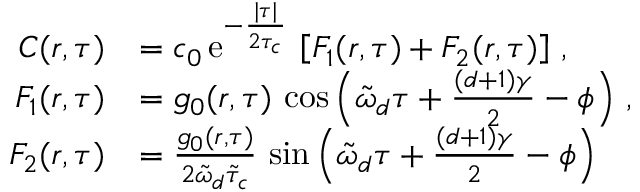Convert formula to latex. <formula><loc_0><loc_0><loc_500><loc_500>\begin{array} { r l } { C ( r , \tau ) } & { = c _ { 0 } \, e ^ { - \frac { | \tau | } { 2 \tau _ { c } } } \, \left [ F _ { 1 } ( r , \tau ) + F _ { 2 } ( r , \tau ) \right ] \, , } \\ { F _ { 1 } ( r , \tau ) } & { = g _ { 0 } ( r , \tau ) \, \cos \left ( \tilde { \omega } _ { d } \tau + \frac { ( d + 1 ) \gamma } { 2 } - \phi \right ) \, , } \\ { F _ { 2 } ( r , \tau ) } & { = \frac { g _ { 0 } ( r , \tau ) } { 2 \tilde { \omega } _ { d } \tilde { \tau } _ { c } } \, \sin \left ( \tilde { \omega } _ { d } \tau + \frac { ( d + 1 ) \gamma } { 2 } - \phi \right ) } \end{array}</formula> 